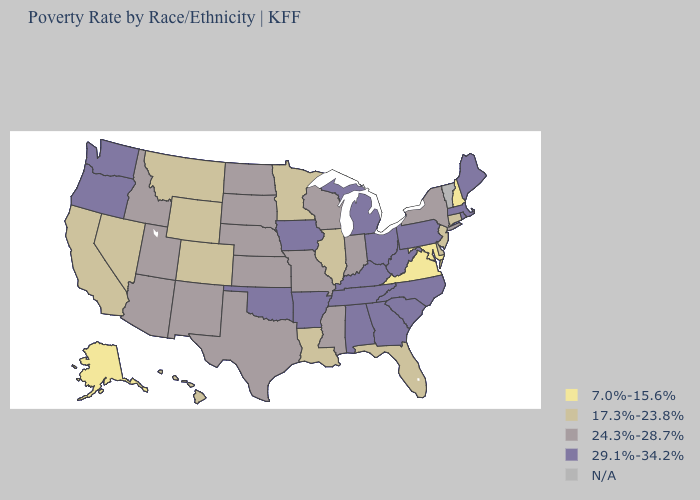What is the value of Minnesota?
Keep it brief. 17.3%-23.8%. Name the states that have a value in the range 24.3%-28.7%?
Give a very brief answer. Arizona, Idaho, Indiana, Kansas, Mississippi, Missouri, Nebraska, New Mexico, New York, North Dakota, South Dakota, Texas, Utah, Wisconsin. Among the states that border Connecticut , does New York have the lowest value?
Quick response, please. Yes. What is the lowest value in the Northeast?
Write a very short answer. 7.0%-15.6%. Name the states that have a value in the range N/A?
Quick response, please. Vermont. What is the lowest value in states that border Vermont?
Be succinct. 7.0%-15.6%. Among the states that border Utah , which have the highest value?
Give a very brief answer. Arizona, Idaho, New Mexico. Does the first symbol in the legend represent the smallest category?
Give a very brief answer. Yes. What is the lowest value in the USA?
Write a very short answer. 7.0%-15.6%. What is the value of Mississippi?
Short answer required. 24.3%-28.7%. Among the states that border Missouri , which have the lowest value?
Give a very brief answer. Illinois. Among the states that border Virginia , which have the lowest value?
Be succinct. Maryland. Is the legend a continuous bar?
Write a very short answer. No. Does Delaware have the lowest value in the USA?
Write a very short answer. No. 